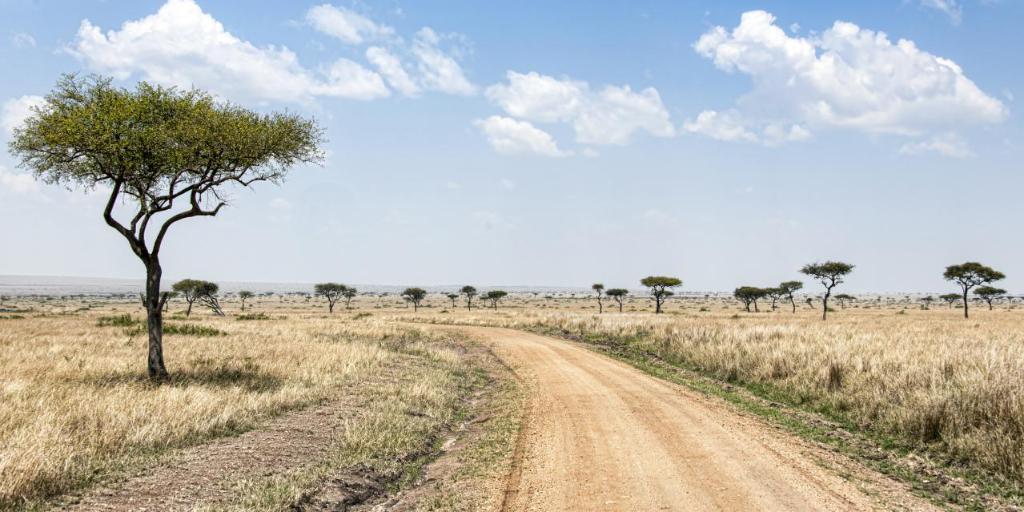How would you summarize this image in a sentence or two? This image is taken outdoors. At the top of the image there is a sky with clouds. At the bottom of the image there is a ground with grass on it. In the background there are a few trees and plants on the ground. 